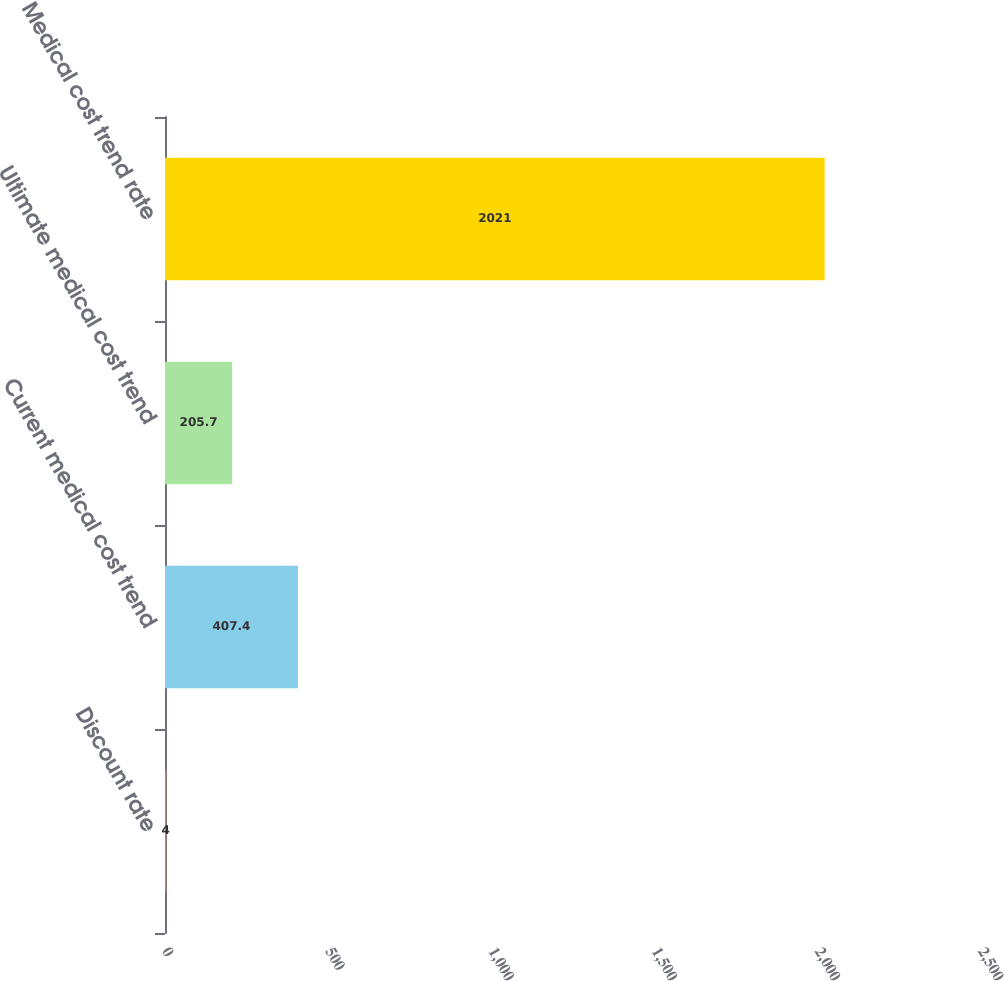Convert chart to OTSL. <chart><loc_0><loc_0><loc_500><loc_500><bar_chart><fcel>Discount rate<fcel>Current medical cost trend<fcel>Ultimate medical cost trend<fcel>Medical cost trend rate<nl><fcel>4<fcel>407.4<fcel>205.7<fcel>2021<nl></chart> 